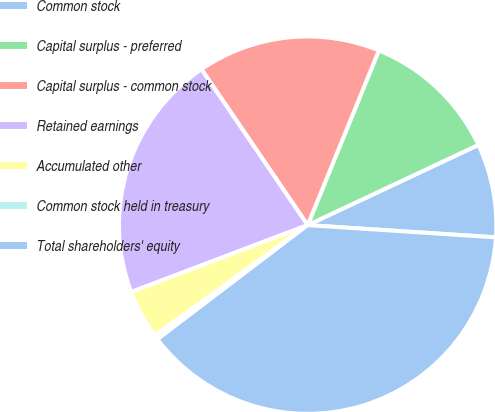Convert chart. <chart><loc_0><loc_0><loc_500><loc_500><pie_chart><fcel>Common stock<fcel>Capital surplus - preferred<fcel>Capital surplus - common stock<fcel>Retained earnings<fcel>Accumulated other<fcel>Common stock held in treasury<fcel>Total shareholders' equity<nl><fcel>8.02%<fcel>11.85%<fcel>15.68%<fcel>21.25%<fcel>4.2%<fcel>0.37%<fcel>38.63%<nl></chart> 